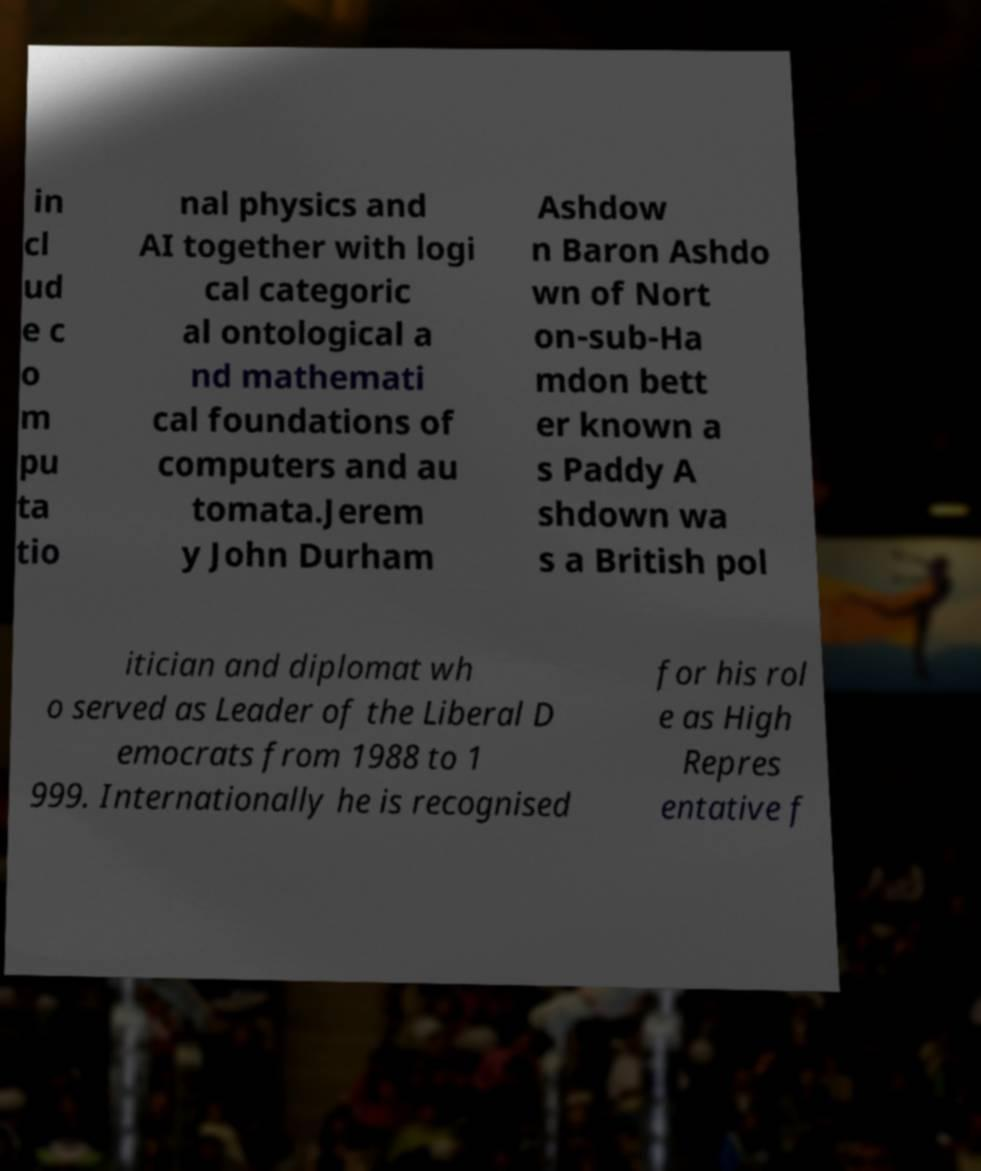What messages or text are displayed in this image? I need them in a readable, typed format. in cl ud e c o m pu ta tio nal physics and AI together with logi cal categoric al ontological a nd mathemati cal foundations of computers and au tomata.Jerem y John Durham Ashdow n Baron Ashdo wn of Nort on-sub-Ha mdon bett er known a s Paddy A shdown wa s a British pol itician and diplomat wh o served as Leader of the Liberal D emocrats from 1988 to 1 999. Internationally he is recognised for his rol e as High Repres entative f 